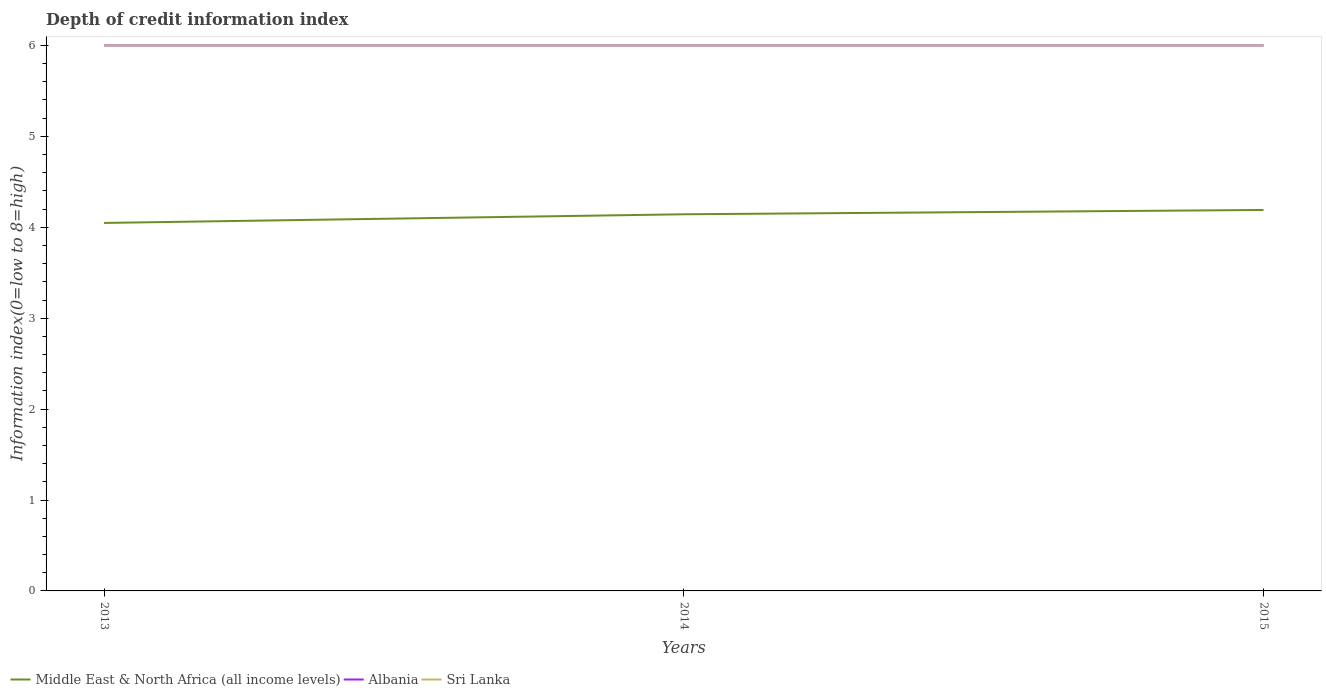How many different coloured lines are there?
Your response must be concise. 3. Does the line corresponding to Middle East & North Africa (all income levels) intersect with the line corresponding to Sri Lanka?
Provide a short and direct response. No. Is the number of lines equal to the number of legend labels?
Provide a short and direct response. Yes. Across all years, what is the maximum information index in Sri Lanka?
Provide a succinct answer. 6. In which year was the information index in Sri Lanka maximum?
Offer a terse response. 2013. What is the total information index in Albania in the graph?
Give a very brief answer. 0. Is the information index in Middle East & North Africa (all income levels) strictly greater than the information index in Albania over the years?
Keep it short and to the point. Yes. How many lines are there?
Keep it short and to the point. 3. How many years are there in the graph?
Provide a succinct answer. 3. Are the values on the major ticks of Y-axis written in scientific E-notation?
Provide a short and direct response. No. Does the graph contain any zero values?
Make the answer very short. No. Does the graph contain grids?
Offer a terse response. No. How many legend labels are there?
Keep it short and to the point. 3. How are the legend labels stacked?
Your answer should be very brief. Horizontal. What is the title of the graph?
Your answer should be very brief. Depth of credit information index. Does "Indonesia" appear as one of the legend labels in the graph?
Your answer should be very brief. No. What is the label or title of the Y-axis?
Keep it short and to the point. Information index(0=low to 8=high). What is the Information index(0=low to 8=high) in Middle East & North Africa (all income levels) in 2013?
Your response must be concise. 4.05. What is the Information index(0=low to 8=high) in Albania in 2013?
Your response must be concise. 6. What is the Information index(0=low to 8=high) in Sri Lanka in 2013?
Provide a short and direct response. 6. What is the Information index(0=low to 8=high) of Middle East & North Africa (all income levels) in 2014?
Provide a short and direct response. 4.14. What is the Information index(0=low to 8=high) of Albania in 2014?
Offer a very short reply. 6. What is the Information index(0=low to 8=high) in Sri Lanka in 2014?
Your answer should be compact. 6. What is the Information index(0=low to 8=high) of Middle East & North Africa (all income levels) in 2015?
Make the answer very short. 4.19. What is the Information index(0=low to 8=high) of Sri Lanka in 2015?
Provide a succinct answer. 6. Across all years, what is the maximum Information index(0=low to 8=high) of Middle East & North Africa (all income levels)?
Ensure brevity in your answer.  4.19. Across all years, what is the minimum Information index(0=low to 8=high) of Middle East & North Africa (all income levels)?
Your answer should be compact. 4.05. What is the total Information index(0=low to 8=high) in Middle East & North Africa (all income levels) in the graph?
Make the answer very short. 12.38. What is the difference between the Information index(0=low to 8=high) in Middle East & North Africa (all income levels) in 2013 and that in 2014?
Offer a terse response. -0.1. What is the difference between the Information index(0=low to 8=high) of Sri Lanka in 2013 and that in 2014?
Your answer should be compact. 0. What is the difference between the Information index(0=low to 8=high) in Middle East & North Africa (all income levels) in 2013 and that in 2015?
Your response must be concise. -0.14. What is the difference between the Information index(0=low to 8=high) in Sri Lanka in 2013 and that in 2015?
Your answer should be very brief. 0. What is the difference between the Information index(0=low to 8=high) of Middle East & North Africa (all income levels) in 2014 and that in 2015?
Offer a very short reply. -0.05. What is the difference between the Information index(0=low to 8=high) in Sri Lanka in 2014 and that in 2015?
Offer a terse response. 0. What is the difference between the Information index(0=low to 8=high) of Middle East & North Africa (all income levels) in 2013 and the Information index(0=low to 8=high) of Albania in 2014?
Make the answer very short. -1.95. What is the difference between the Information index(0=low to 8=high) of Middle East & North Africa (all income levels) in 2013 and the Information index(0=low to 8=high) of Sri Lanka in 2014?
Your response must be concise. -1.95. What is the difference between the Information index(0=low to 8=high) of Middle East & North Africa (all income levels) in 2013 and the Information index(0=low to 8=high) of Albania in 2015?
Provide a short and direct response. -1.95. What is the difference between the Information index(0=low to 8=high) of Middle East & North Africa (all income levels) in 2013 and the Information index(0=low to 8=high) of Sri Lanka in 2015?
Ensure brevity in your answer.  -1.95. What is the difference between the Information index(0=low to 8=high) in Middle East & North Africa (all income levels) in 2014 and the Information index(0=low to 8=high) in Albania in 2015?
Ensure brevity in your answer.  -1.86. What is the difference between the Information index(0=low to 8=high) in Middle East & North Africa (all income levels) in 2014 and the Information index(0=low to 8=high) in Sri Lanka in 2015?
Give a very brief answer. -1.86. What is the difference between the Information index(0=low to 8=high) of Albania in 2014 and the Information index(0=low to 8=high) of Sri Lanka in 2015?
Give a very brief answer. 0. What is the average Information index(0=low to 8=high) in Middle East & North Africa (all income levels) per year?
Keep it short and to the point. 4.13. What is the average Information index(0=low to 8=high) in Albania per year?
Offer a terse response. 6. What is the average Information index(0=low to 8=high) of Sri Lanka per year?
Your answer should be very brief. 6. In the year 2013, what is the difference between the Information index(0=low to 8=high) in Middle East & North Africa (all income levels) and Information index(0=low to 8=high) in Albania?
Ensure brevity in your answer.  -1.95. In the year 2013, what is the difference between the Information index(0=low to 8=high) in Middle East & North Africa (all income levels) and Information index(0=low to 8=high) in Sri Lanka?
Your answer should be very brief. -1.95. In the year 2013, what is the difference between the Information index(0=low to 8=high) in Albania and Information index(0=low to 8=high) in Sri Lanka?
Your response must be concise. 0. In the year 2014, what is the difference between the Information index(0=low to 8=high) in Middle East & North Africa (all income levels) and Information index(0=low to 8=high) in Albania?
Your answer should be compact. -1.86. In the year 2014, what is the difference between the Information index(0=low to 8=high) in Middle East & North Africa (all income levels) and Information index(0=low to 8=high) in Sri Lanka?
Keep it short and to the point. -1.86. In the year 2015, what is the difference between the Information index(0=low to 8=high) of Middle East & North Africa (all income levels) and Information index(0=low to 8=high) of Albania?
Make the answer very short. -1.81. In the year 2015, what is the difference between the Information index(0=low to 8=high) in Middle East & North Africa (all income levels) and Information index(0=low to 8=high) in Sri Lanka?
Offer a terse response. -1.81. What is the ratio of the Information index(0=low to 8=high) in Middle East & North Africa (all income levels) in 2013 to that in 2014?
Offer a very short reply. 0.98. What is the ratio of the Information index(0=low to 8=high) of Albania in 2013 to that in 2014?
Offer a terse response. 1. What is the ratio of the Information index(0=low to 8=high) in Sri Lanka in 2013 to that in 2014?
Your answer should be very brief. 1. What is the ratio of the Information index(0=low to 8=high) in Middle East & North Africa (all income levels) in 2013 to that in 2015?
Provide a short and direct response. 0.97. What is the ratio of the Information index(0=low to 8=high) of Middle East & North Africa (all income levels) in 2014 to that in 2015?
Ensure brevity in your answer.  0.99. What is the difference between the highest and the second highest Information index(0=low to 8=high) of Middle East & North Africa (all income levels)?
Give a very brief answer. 0.05. What is the difference between the highest and the second highest Information index(0=low to 8=high) of Albania?
Provide a short and direct response. 0. What is the difference between the highest and the second highest Information index(0=low to 8=high) in Sri Lanka?
Provide a succinct answer. 0. What is the difference between the highest and the lowest Information index(0=low to 8=high) of Middle East & North Africa (all income levels)?
Keep it short and to the point. 0.14. What is the difference between the highest and the lowest Information index(0=low to 8=high) in Albania?
Your answer should be compact. 0. What is the difference between the highest and the lowest Information index(0=low to 8=high) of Sri Lanka?
Your answer should be very brief. 0. 